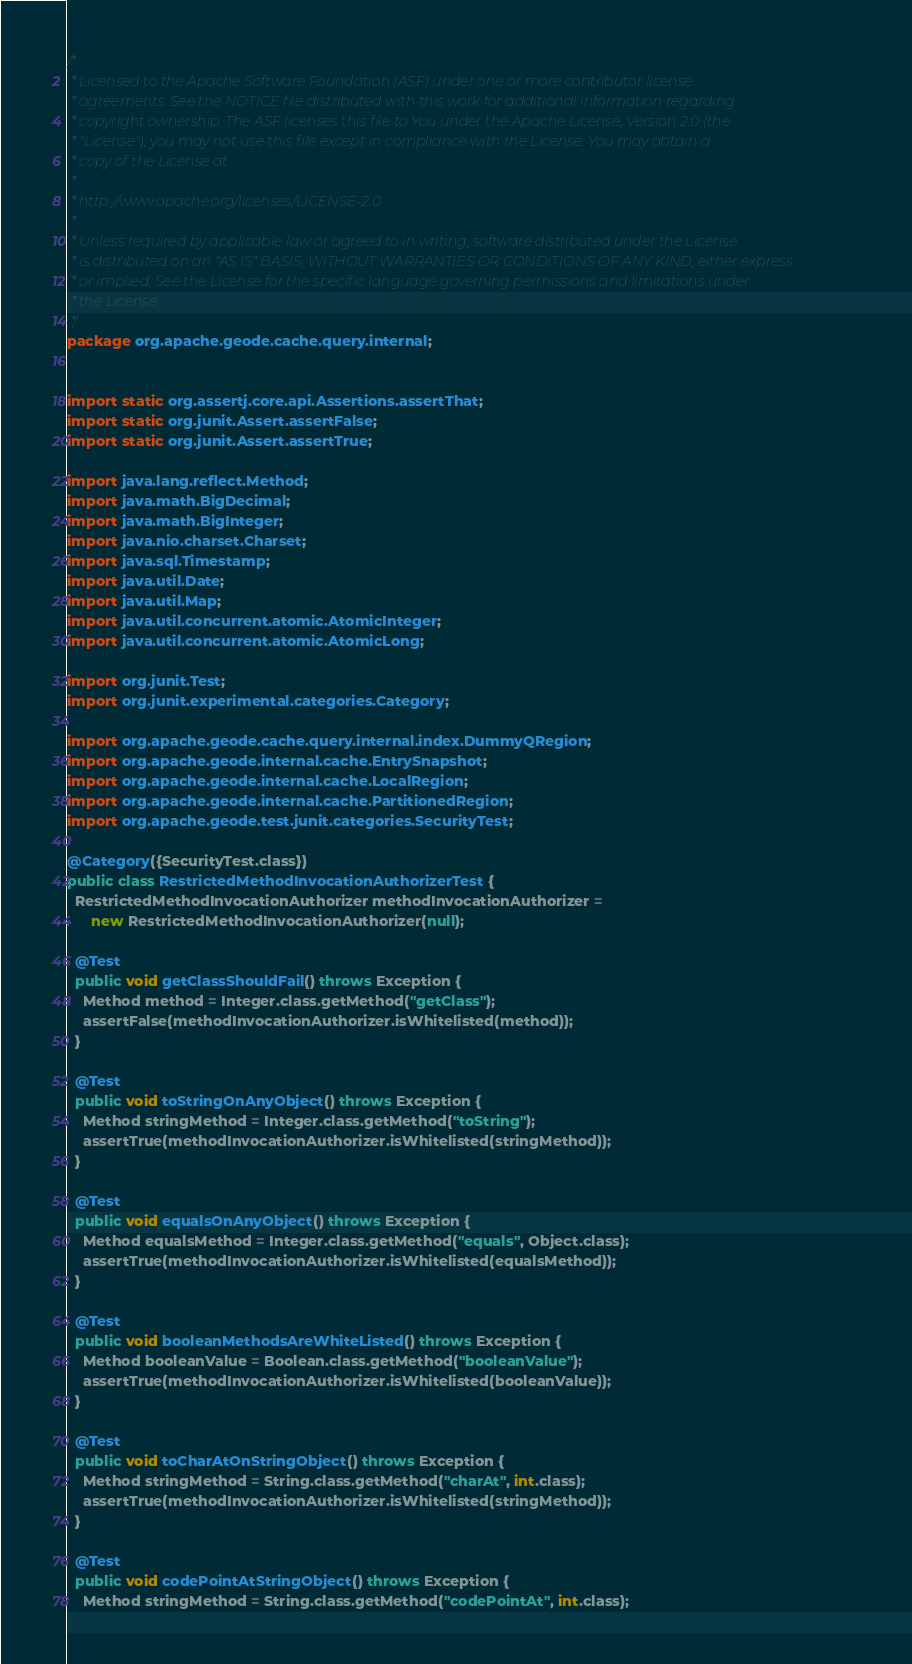<code> <loc_0><loc_0><loc_500><loc_500><_Java_>/*
 * Licensed to the Apache Software Foundation (ASF) under one or more contributor license
 * agreements. See the NOTICE file distributed with this work for additional information regarding
 * copyright ownership. The ASF licenses this file to You under the Apache License, Version 2.0 (the
 * "License"); you may not use this file except in compliance with the License. You may obtain a
 * copy of the License at
 *
 * http://www.apache.org/licenses/LICENSE-2.0
 *
 * Unless required by applicable law or agreed to in writing, software distributed under the License
 * is distributed on an "AS IS" BASIS, WITHOUT WARRANTIES OR CONDITIONS OF ANY KIND, either express
 * or implied. See the License for the specific language governing permissions and limitations under
 * the License.
 */
package org.apache.geode.cache.query.internal;


import static org.assertj.core.api.Assertions.assertThat;
import static org.junit.Assert.assertFalse;
import static org.junit.Assert.assertTrue;

import java.lang.reflect.Method;
import java.math.BigDecimal;
import java.math.BigInteger;
import java.nio.charset.Charset;
import java.sql.Timestamp;
import java.util.Date;
import java.util.Map;
import java.util.concurrent.atomic.AtomicInteger;
import java.util.concurrent.atomic.AtomicLong;

import org.junit.Test;
import org.junit.experimental.categories.Category;

import org.apache.geode.cache.query.internal.index.DummyQRegion;
import org.apache.geode.internal.cache.EntrySnapshot;
import org.apache.geode.internal.cache.LocalRegion;
import org.apache.geode.internal.cache.PartitionedRegion;
import org.apache.geode.test.junit.categories.SecurityTest;

@Category({SecurityTest.class})
public class RestrictedMethodInvocationAuthorizerTest {
  RestrictedMethodInvocationAuthorizer methodInvocationAuthorizer =
      new RestrictedMethodInvocationAuthorizer(null);

  @Test
  public void getClassShouldFail() throws Exception {
    Method method = Integer.class.getMethod("getClass");
    assertFalse(methodInvocationAuthorizer.isWhitelisted(method));
  }

  @Test
  public void toStringOnAnyObject() throws Exception {
    Method stringMethod = Integer.class.getMethod("toString");
    assertTrue(methodInvocationAuthorizer.isWhitelisted(stringMethod));
  }

  @Test
  public void equalsOnAnyObject() throws Exception {
    Method equalsMethod = Integer.class.getMethod("equals", Object.class);
    assertTrue(methodInvocationAuthorizer.isWhitelisted(equalsMethod));
  }

  @Test
  public void booleanMethodsAreWhiteListed() throws Exception {
    Method booleanValue = Boolean.class.getMethod("booleanValue");
    assertTrue(methodInvocationAuthorizer.isWhitelisted(booleanValue));
  }

  @Test
  public void toCharAtOnStringObject() throws Exception {
    Method stringMethod = String.class.getMethod("charAt", int.class);
    assertTrue(methodInvocationAuthorizer.isWhitelisted(stringMethod));
  }

  @Test
  public void codePointAtStringObject() throws Exception {
    Method stringMethod = String.class.getMethod("codePointAt", int.class);</code> 